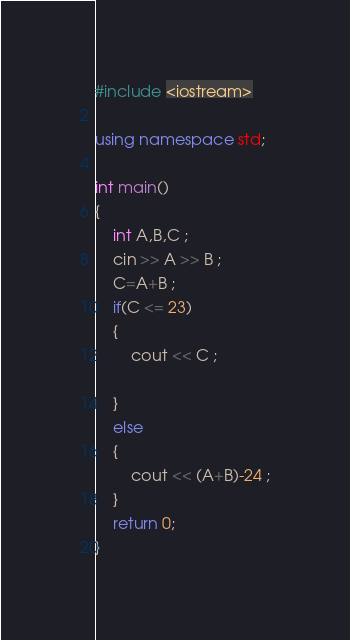<code> <loc_0><loc_0><loc_500><loc_500><_C++_>#include <iostream>

using namespace std;

int main()
{
    int A,B,C ; 
    cin >> A >> B ;
    C=A+B ;
    if(C <= 23)
    {
        cout << C ;
        
    }
    else 
    {
        cout << (A+B)-24 ;
    }
    return 0;
}</code> 